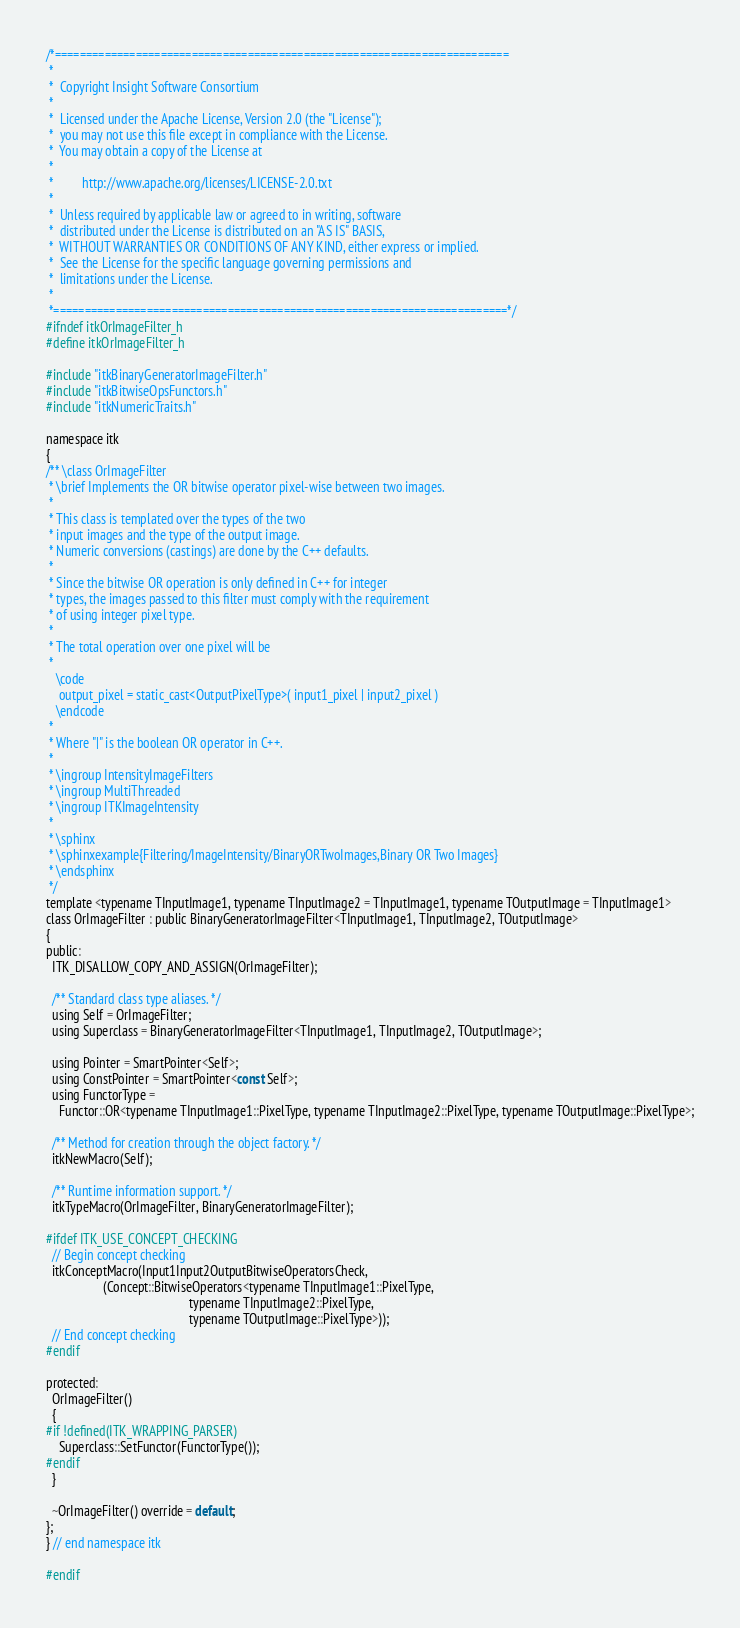Convert code to text. <code><loc_0><loc_0><loc_500><loc_500><_C_>/*=========================================================================
 *
 *  Copyright Insight Software Consortium
 *
 *  Licensed under the Apache License, Version 2.0 (the "License");
 *  you may not use this file except in compliance with the License.
 *  You may obtain a copy of the License at
 *
 *         http://www.apache.org/licenses/LICENSE-2.0.txt
 *
 *  Unless required by applicable law or agreed to in writing, software
 *  distributed under the License is distributed on an "AS IS" BASIS,
 *  WITHOUT WARRANTIES OR CONDITIONS OF ANY KIND, either express or implied.
 *  See the License for the specific language governing permissions and
 *  limitations under the License.
 *
 *=========================================================================*/
#ifndef itkOrImageFilter_h
#define itkOrImageFilter_h

#include "itkBinaryGeneratorImageFilter.h"
#include "itkBitwiseOpsFunctors.h"
#include "itkNumericTraits.h"

namespace itk
{
/** \class OrImageFilter
 * \brief Implements the OR bitwise operator pixel-wise between two images.
 *
 * This class is templated over the types of the two
 * input images and the type of the output image.
 * Numeric conversions (castings) are done by the C++ defaults.
 *
 * Since the bitwise OR operation is only defined in C++ for integer
 * types, the images passed to this filter must comply with the requirement
 * of using integer pixel type.
 *
 * The total operation over one pixel will be
 *
   \code
    output_pixel = static_cast<OutputPixelType>( input1_pixel | input2_pixel )
   \endcode
 *
 * Where "|" is the boolean OR operator in C++.
 *
 * \ingroup IntensityImageFilters
 * \ingroup MultiThreaded
 * \ingroup ITKImageIntensity
 *
 * \sphinx
 * \sphinxexample{Filtering/ImageIntensity/BinaryORTwoImages,Binary OR Two Images}
 * \endsphinx
 */
template <typename TInputImage1, typename TInputImage2 = TInputImage1, typename TOutputImage = TInputImage1>
class OrImageFilter : public BinaryGeneratorImageFilter<TInputImage1, TInputImage2, TOutputImage>
{
public:
  ITK_DISALLOW_COPY_AND_ASSIGN(OrImageFilter);

  /** Standard class type aliases. */
  using Self = OrImageFilter;
  using Superclass = BinaryGeneratorImageFilter<TInputImage1, TInputImage2, TOutputImage>;

  using Pointer = SmartPointer<Self>;
  using ConstPointer = SmartPointer<const Self>;
  using FunctorType =
    Functor::OR<typename TInputImage1::PixelType, typename TInputImage2::PixelType, typename TOutputImage::PixelType>;

  /** Method for creation through the object factory. */
  itkNewMacro(Self);

  /** Runtime information support. */
  itkTypeMacro(OrImageFilter, BinaryGeneratorImageFilter);

#ifdef ITK_USE_CONCEPT_CHECKING
  // Begin concept checking
  itkConceptMacro(Input1Input2OutputBitwiseOperatorsCheck,
                  (Concept::BitwiseOperators<typename TInputImage1::PixelType,
                                             typename TInputImage2::PixelType,
                                             typename TOutputImage::PixelType>));
  // End concept checking
#endif

protected:
  OrImageFilter()
  {
#if !defined(ITK_WRAPPING_PARSER)
    Superclass::SetFunctor(FunctorType());
#endif
  }

  ~OrImageFilter() override = default;
};
} // end namespace itk

#endif
</code> 